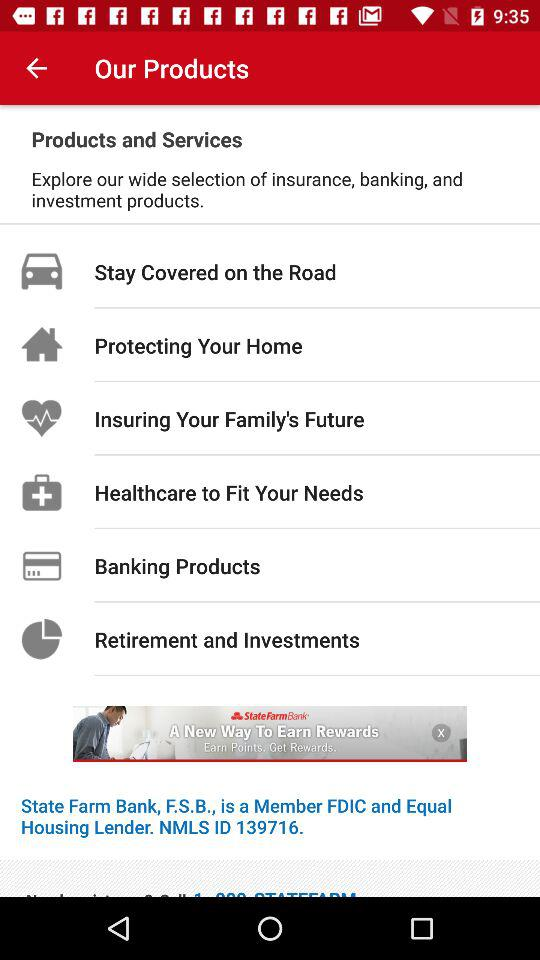What are the different available categories of "Our Products"? The different available categories are "Stay Covered on the Road", "Protecting Your Home", "Insuring Your Family's Future", "Healthcare to Fit Your Needs", "Banking Products" and "Retirement and Investments". 